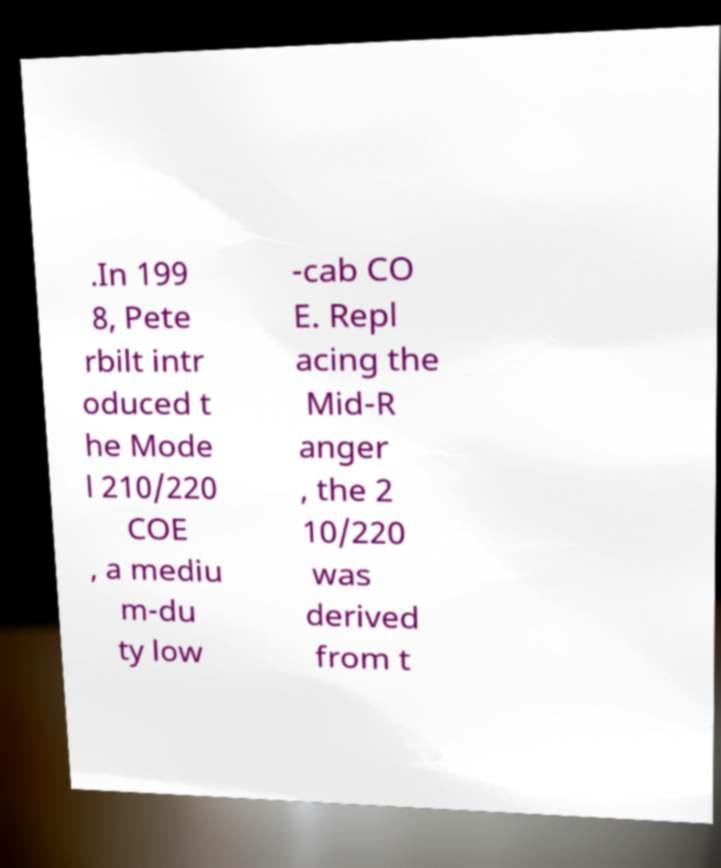What messages or text are displayed in this image? I need them in a readable, typed format. .In 199 8, Pete rbilt intr oduced t he Mode l 210/220 COE , a mediu m-du ty low -cab CO E. Repl acing the Mid-R anger , the 2 10/220 was derived from t 